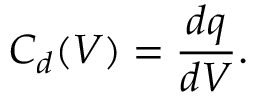<formula> <loc_0><loc_0><loc_500><loc_500>C _ { d } ( V ) = \frac { d q } { d V } .</formula> 